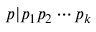<formula> <loc_0><loc_0><loc_500><loc_500>p | p _ { 1 } p _ { 2 } \cdots p _ { k }</formula> 